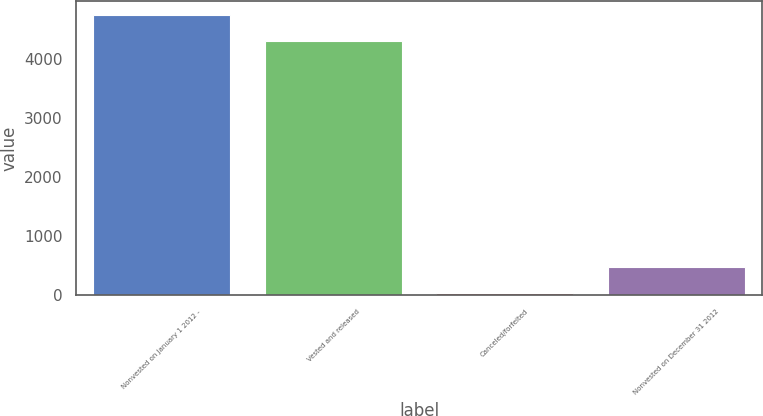Convert chart. <chart><loc_0><loc_0><loc_500><loc_500><bar_chart><fcel>Nonvested on January 1 2012 -<fcel>Vested and released<fcel>Canceled/forfeited<fcel>Nonvested on December 31 2012<nl><fcel>4742<fcel>4302<fcel>44<fcel>484<nl></chart> 